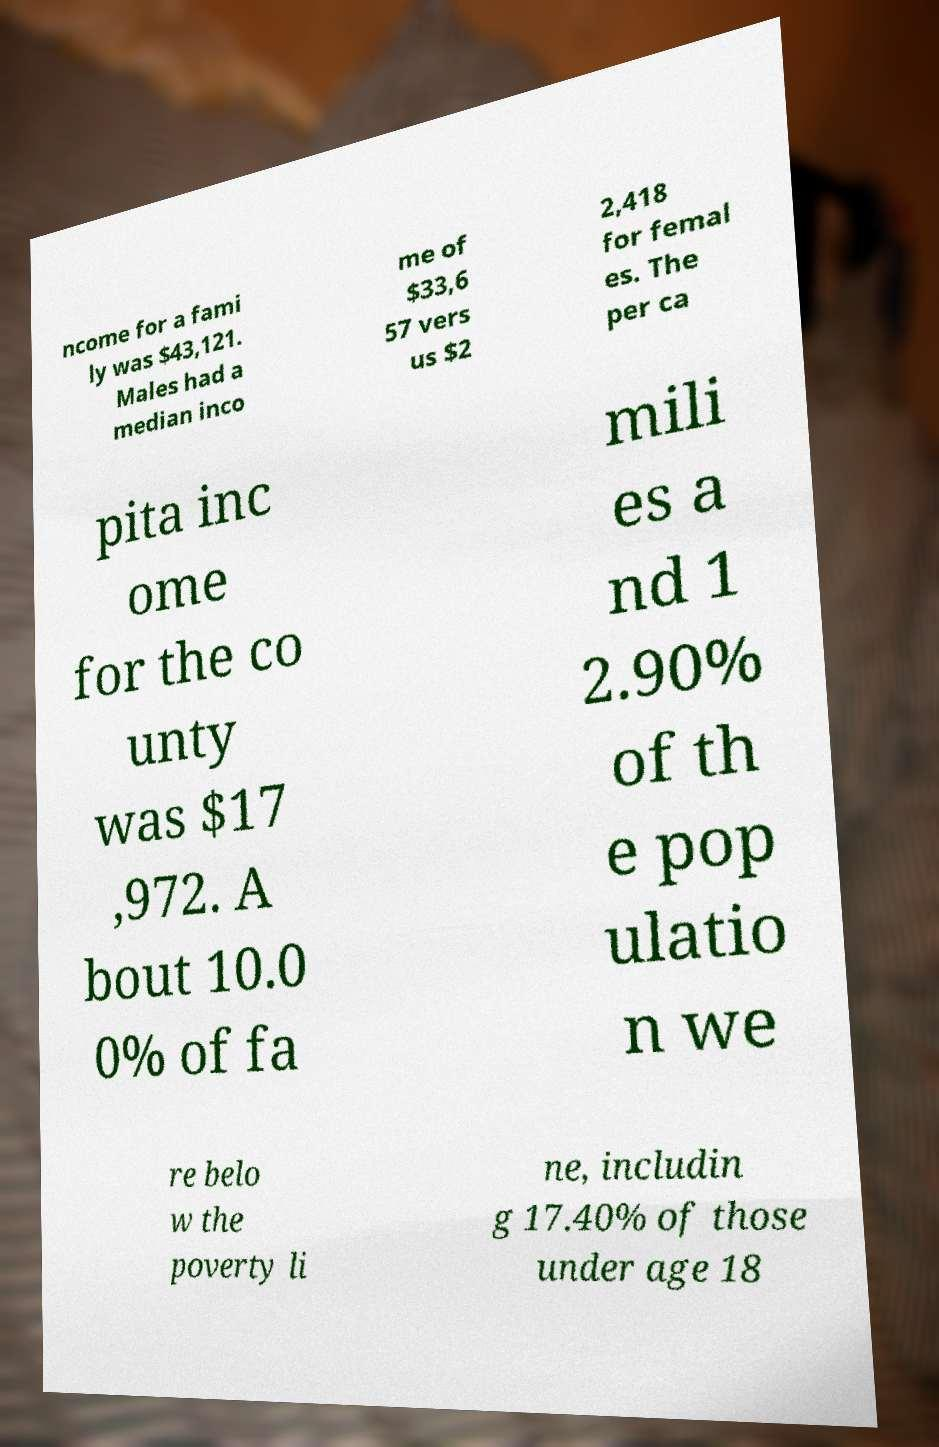Could you assist in decoding the text presented in this image and type it out clearly? ncome for a fami ly was $43,121. Males had a median inco me of $33,6 57 vers us $2 2,418 for femal es. The per ca pita inc ome for the co unty was $17 ,972. A bout 10.0 0% of fa mili es a nd 1 2.90% of th e pop ulatio n we re belo w the poverty li ne, includin g 17.40% of those under age 18 